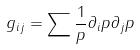<formula> <loc_0><loc_0><loc_500><loc_500>g _ { i j } = \sum \frac { 1 } { p } \partial _ { i } p \partial _ { j } p</formula> 